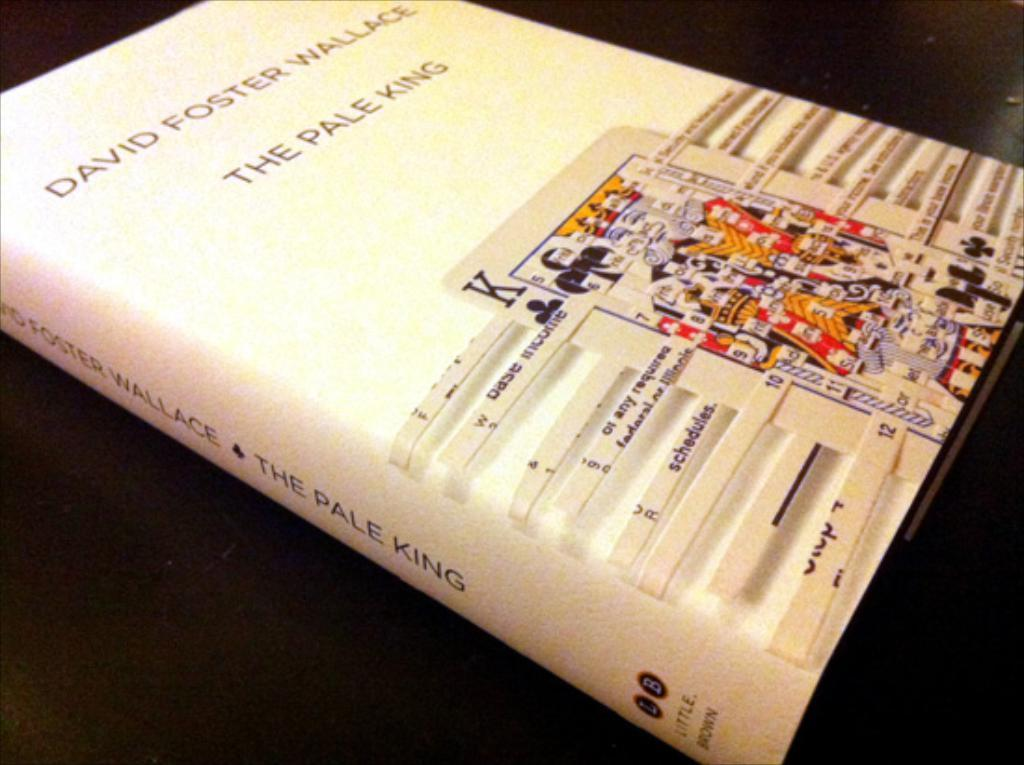<image>
Provide a brief description of the given image. A book titled The Pale king by David Foster Wallace 